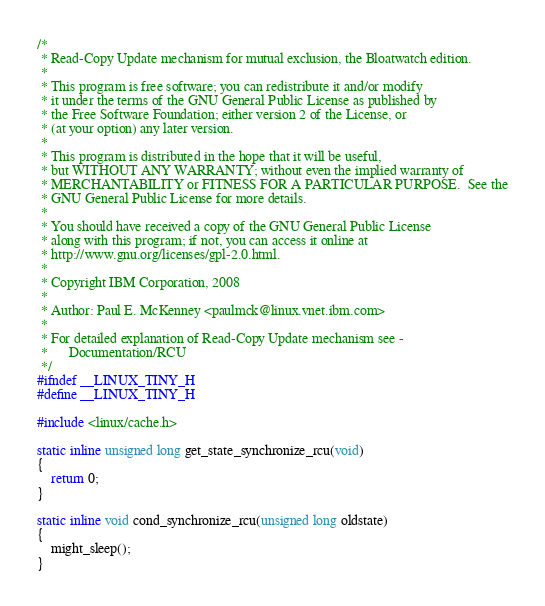<code> <loc_0><loc_0><loc_500><loc_500><_C_>/*
 * Read-Copy Update mechanism for mutual exclusion, the Bloatwatch edition.
 *
 * This program is free software; you can redistribute it and/or modify
 * it under the terms of the GNU General Public License as published by
 * the Free Software Foundation; either version 2 of the License, or
 * (at your option) any later version.
 *
 * This program is distributed in the hope that it will be useful,
 * but WITHOUT ANY WARRANTY; without even the implied warranty of
 * MERCHANTABILITY or FITNESS FOR A PARTICULAR PURPOSE.  See the
 * GNU General Public License for more details.
 *
 * You should have received a copy of the GNU General Public License
 * along with this program; if not, you can access it online at
 * http://www.gnu.org/licenses/gpl-2.0.html.
 *
 * Copyright IBM Corporation, 2008
 *
 * Author: Paul E. McKenney <paulmck@linux.vnet.ibm.com>
 *
 * For detailed explanation of Read-Copy Update mechanism see -
 *		Documentation/RCU
 */
#ifndef __LINUX_TINY_H
#define __LINUX_TINY_H

#include <linux/cache.h>

static inline unsigned long get_state_synchronize_rcu(void)
{
	return 0;
}

static inline void cond_synchronize_rcu(unsigned long oldstate)
{
	might_sleep();
}
</code> 